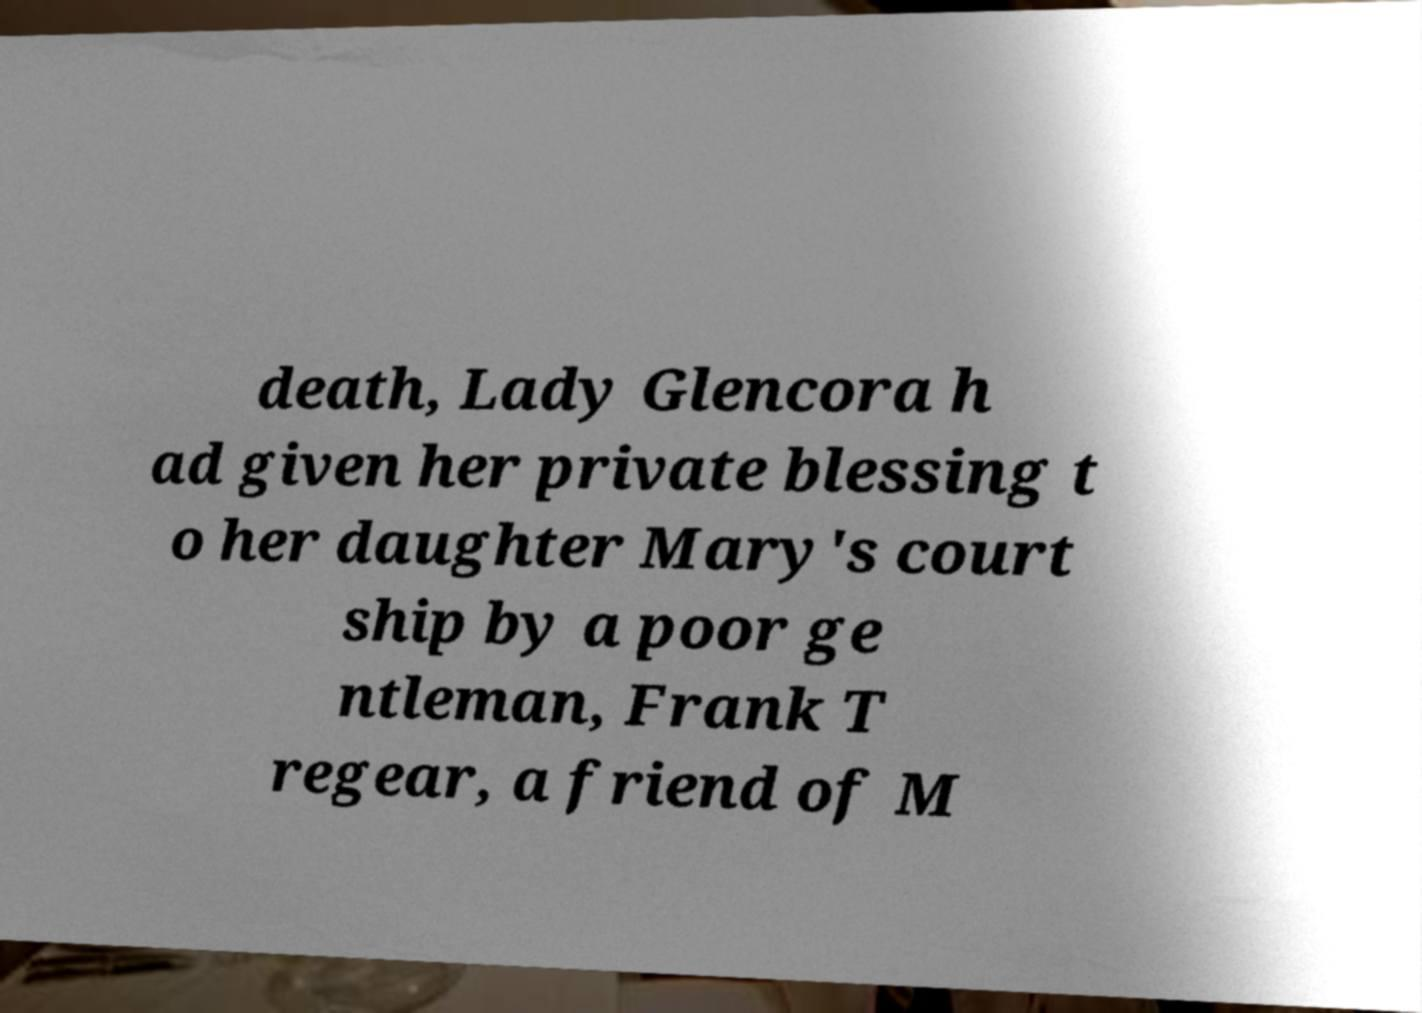There's text embedded in this image that I need extracted. Can you transcribe it verbatim? death, Lady Glencora h ad given her private blessing t o her daughter Mary's court ship by a poor ge ntleman, Frank T regear, a friend of M 